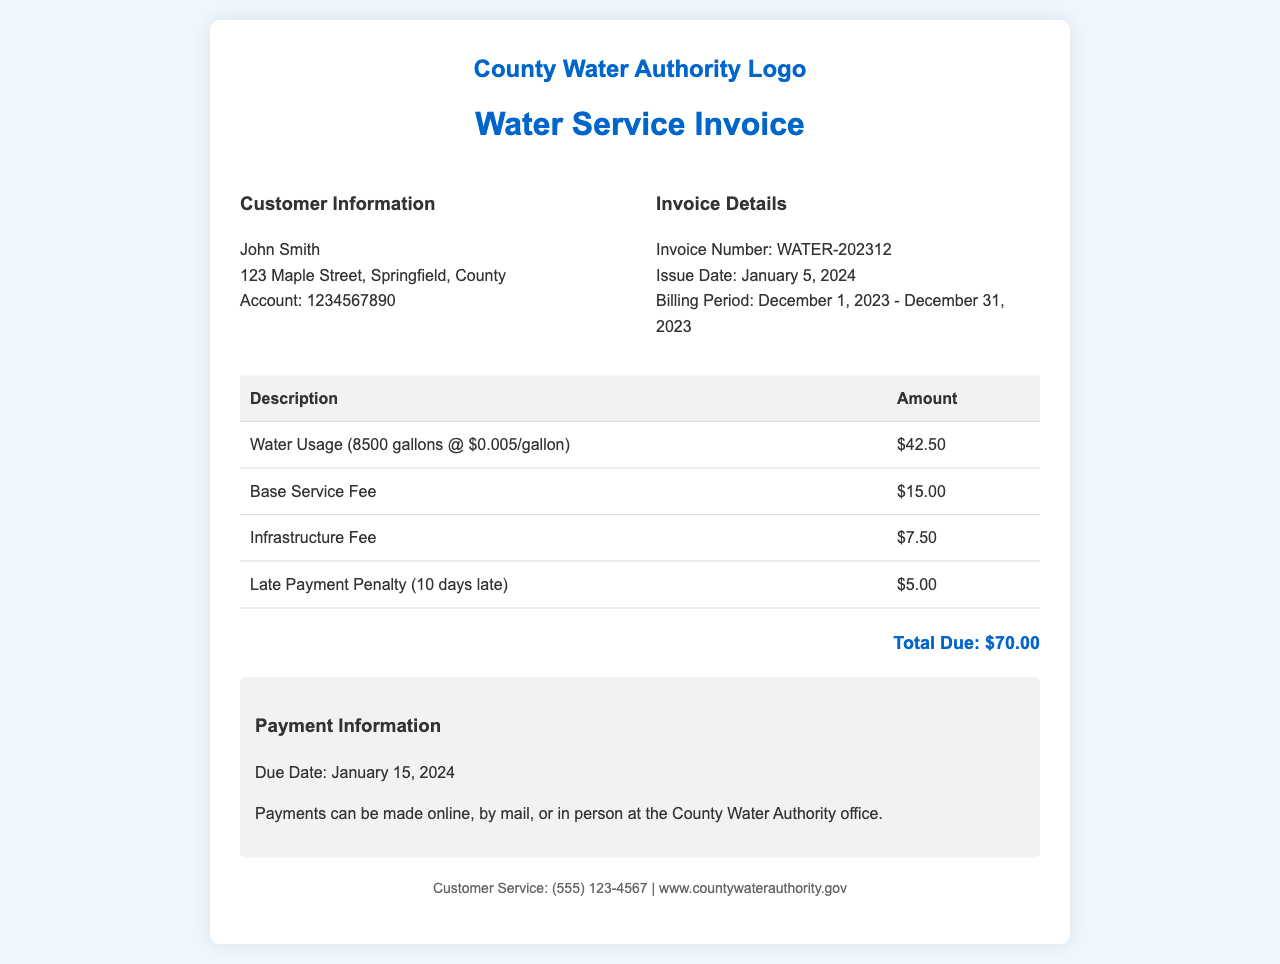What is the total amount due? The total amount due is listed at the bottom of the invoice, which is $70.00.
Answer: $70.00 What is the invoice number? The invoice number can be found in the invoice details section, which is WATER-202312.
Answer: WATER-202312 What is the customer account number? The customer account number is specified in the customer information section, which is 1234567890.
Answer: 1234567890 What is the due date for the payment? The due date for the payment is stated in the payment information section, which is January 15, 2024.
Answer: January 15, 2024 How much was charged for water usage? The charge for water usage is detailed in the table, which states $42.50 for 8500 gallons.
Answer: $42.50 What fee is imposed for late payment? The late payment penalty is listed in the table as $5.00 for 10 days late.
Answer: $5.00 What is the base service fee? The base service fee is included in the charges on the invoice, which is $15.00.
Answer: $15.00 What period does this invoice cover? The billing period is indicated in the invoice details as December 1, 2023 - December 31, 2023.
Answer: December 1, 2023 - December 31, 2023 What agency issued this invoice? The agency responsible for this invoice is referred to in the header section as the County Water Authority.
Answer: County Water Authority 